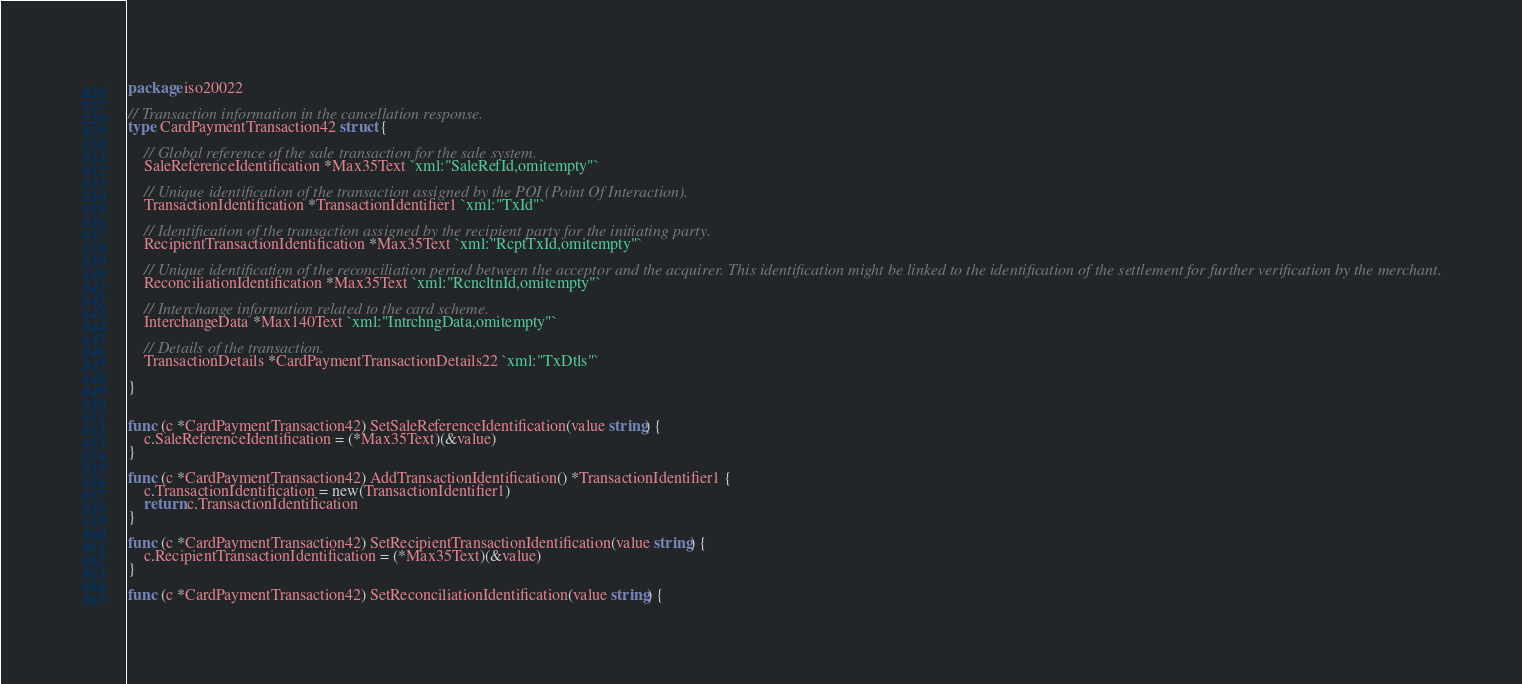<code> <loc_0><loc_0><loc_500><loc_500><_Go_>package iso20022

// Transaction information in the cancellation response.
type CardPaymentTransaction42 struct {

	// Global reference of the sale transaction for the sale system.
	SaleReferenceIdentification *Max35Text `xml:"SaleRefId,omitempty"`

	// Unique identification of the transaction assigned by the POI (Point Of Interaction).
	TransactionIdentification *TransactionIdentifier1 `xml:"TxId"`

	// Identification of the transaction assigned by the recipient party for the initiating party.
	RecipientTransactionIdentification *Max35Text `xml:"RcptTxId,omitempty"`

	// Unique identification of the reconciliation period between the acceptor and the acquirer. This identification might be linked to the identification of the settlement for further verification by the merchant.
	ReconciliationIdentification *Max35Text `xml:"RcncltnId,omitempty"`

	// Interchange information related to the card scheme.
	InterchangeData *Max140Text `xml:"IntrchngData,omitempty"`

	// Details of the transaction.
	TransactionDetails *CardPaymentTransactionDetails22 `xml:"TxDtls"`

}


func (c *CardPaymentTransaction42) SetSaleReferenceIdentification(value string) {
	c.SaleReferenceIdentification = (*Max35Text)(&value)
}

func (c *CardPaymentTransaction42) AddTransactionIdentification() *TransactionIdentifier1 {
	c.TransactionIdentification = new(TransactionIdentifier1)
	return c.TransactionIdentification
}

func (c *CardPaymentTransaction42) SetRecipientTransactionIdentification(value string) {
	c.RecipientTransactionIdentification = (*Max35Text)(&value)
}

func (c *CardPaymentTransaction42) SetReconciliationIdentification(value string) {</code> 